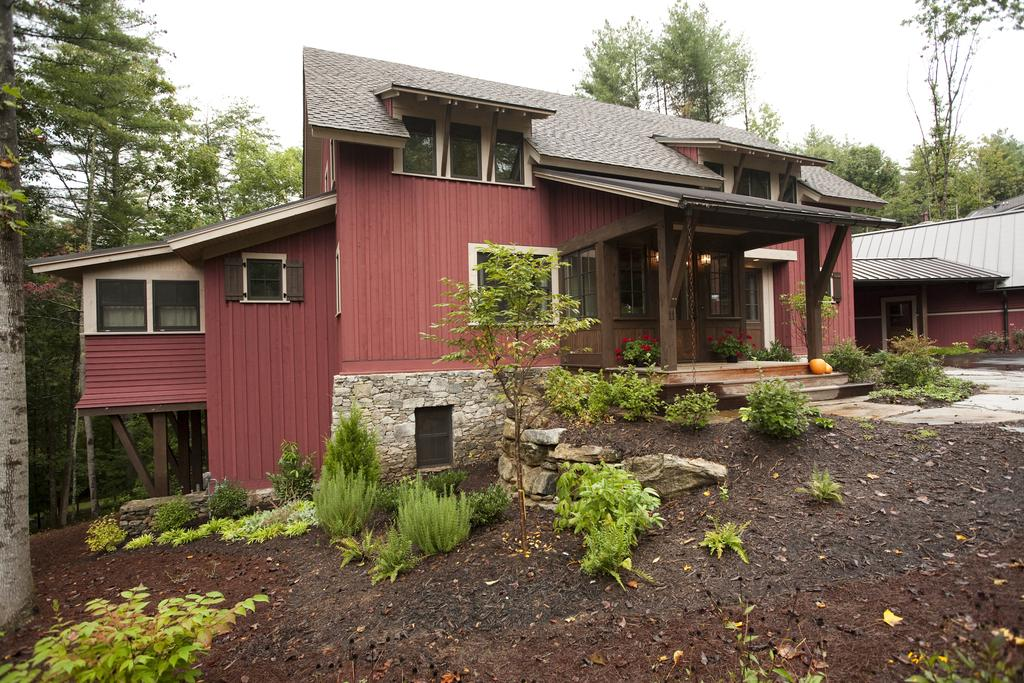What type of structure is present in the image? There is a shed in the image. What can be seen in the distance behind the shed? There are trees in the background of the image. What type of vegetation is visible in the image? There are plants in the image. What is visible at the bottom of the image? The ground is visible at the bottom of the image. What type of pin is holding the shed together in the image? There is no pin visible in the image; the shed appears to be held together by other means. 